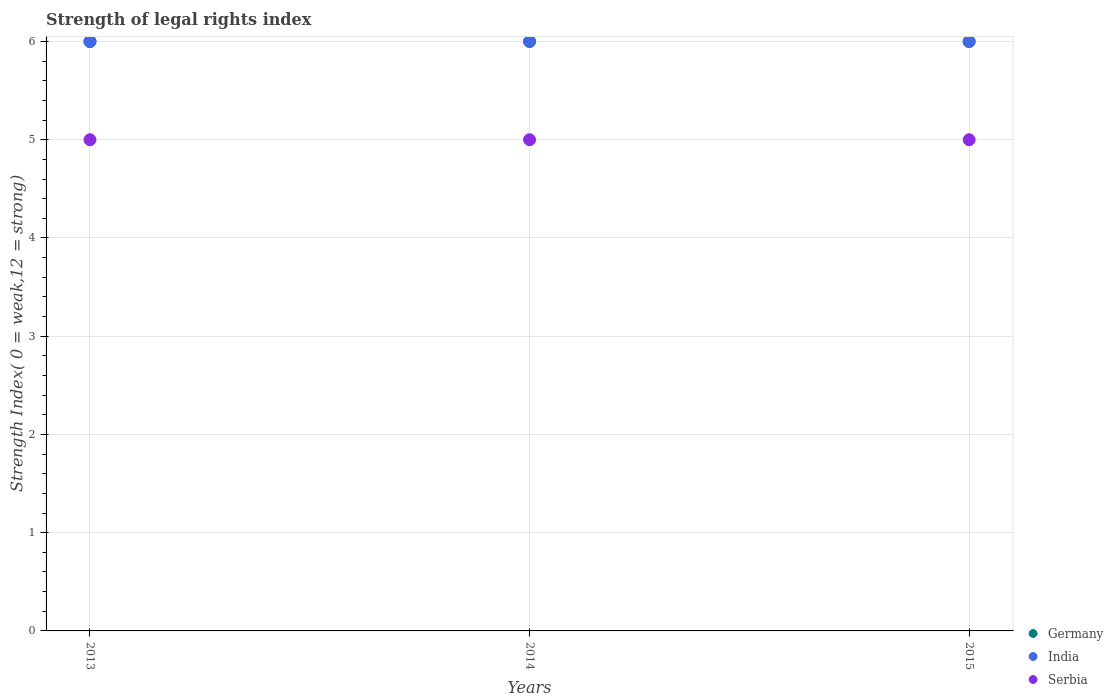Is the number of dotlines equal to the number of legend labels?
Ensure brevity in your answer.  Yes. Across all years, what is the maximum strength index in Germany?
Provide a succinct answer. 6. In which year was the strength index in India minimum?
Give a very brief answer. 2013. What is the total strength index in Serbia in the graph?
Offer a very short reply. 15. What is the difference between the strength index in Serbia in 2015 and the strength index in India in 2014?
Your answer should be very brief. -1. In the year 2015, what is the difference between the strength index in India and strength index in Serbia?
Ensure brevity in your answer.  1. What is the ratio of the strength index in Germany in 2014 to that in 2015?
Give a very brief answer. 1. What is the difference between the highest and the lowest strength index in Serbia?
Your answer should be very brief. 0. In how many years, is the strength index in Serbia greater than the average strength index in Serbia taken over all years?
Your answer should be compact. 0. Is the sum of the strength index in Germany in 2013 and 2014 greater than the maximum strength index in India across all years?
Your answer should be very brief. Yes. Is the strength index in Serbia strictly greater than the strength index in India over the years?
Provide a short and direct response. No. Is the strength index in Germany strictly less than the strength index in India over the years?
Make the answer very short. No. Are the values on the major ticks of Y-axis written in scientific E-notation?
Ensure brevity in your answer.  No. Does the graph contain grids?
Your answer should be very brief. Yes. How many legend labels are there?
Make the answer very short. 3. What is the title of the graph?
Your answer should be very brief. Strength of legal rights index. What is the label or title of the X-axis?
Make the answer very short. Years. What is the label or title of the Y-axis?
Ensure brevity in your answer.  Strength Index( 0 = weak,12 = strong). What is the Strength Index( 0 = weak,12 = strong) in Germany in 2013?
Provide a short and direct response. 6. What is the Strength Index( 0 = weak,12 = strong) of India in 2013?
Ensure brevity in your answer.  6. What is the Strength Index( 0 = weak,12 = strong) in Serbia in 2013?
Provide a short and direct response. 5. What is the Strength Index( 0 = weak,12 = strong) in India in 2014?
Keep it short and to the point. 6. What is the Strength Index( 0 = weak,12 = strong) in Serbia in 2014?
Your answer should be very brief. 5. What is the Strength Index( 0 = weak,12 = strong) of India in 2015?
Give a very brief answer. 6. What is the Strength Index( 0 = weak,12 = strong) of Serbia in 2015?
Ensure brevity in your answer.  5. Across all years, what is the maximum Strength Index( 0 = weak,12 = strong) in Germany?
Make the answer very short. 6. Across all years, what is the minimum Strength Index( 0 = weak,12 = strong) of Germany?
Your answer should be compact. 6. What is the total Strength Index( 0 = weak,12 = strong) of Serbia in the graph?
Your response must be concise. 15. What is the difference between the Strength Index( 0 = weak,12 = strong) in India in 2013 and that in 2014?
Your response must be concise. 0. What is the difference between the Strength Index( 0 = weak,12 = strong) of Serbia in 2013 and that in 2014?
Give a very brief answer. 0. What is the difference between the Strength Index( 0 = weak,12 = strong) in India in 2014 and that in 2015?
Provide a succinct answer. 0. What is the difference between the Strength Index( 0 = weak,12 = strong) in Germany in 2013 and the Strength Index( 0 = weak,12 = strong) in India in 2014?
Provide a succinct answer. 0. What is the difference between the Strength Index( 0 = weak,12 = strong) of Germany in 2013 and the Strength Index( 0 = weak,12 = strong) of Serbia in 2014?
Your answer should be very brief. 1. What is the difference between the Strength Index( 0 = weak,12 = strong) of India in 2013 and the Strength Index( 0 = weak,12 = strong) of Serbia in 2014?
Provide a short and direct response. 1. What is the difference between the Strength Index( 0 = weak,12 = strong) of Germany in 2013 and the Strength Index( 0 = weak,12 = strong) of Serbia in 2015?
Provide a succinct answer. 1. What is the difference between the Strength Index( 0 = weak,12 = strong) of Germany in 2014 and the Strength Index( 0 = weak,12 = strong) of Serbia in 2015?
Offer a terse response. 1. What is the difference between the Strength Index( 0 = weak,12 = strong) of India in 2014 and the Strength Index( 0 = weak,12 = strong) of Serbia in 2015?
Your response must be concise. 1. What is the average Strength Index( 0 = weak,12 = strong) of Germany per year?
Offer a terse response. 6. In the year 2013, what is the difference between the Strength Index( 0 = weak,12 = strong) in Germany and Strength Index( 0 = weak,12 = strong) in India?
Provide a short and direct response. 0. In the year 2013, what is the difference between the Strength Index( 0 = weak,12 = strong) of Germany and Strength Index( 0 = weak,12 = strong) of Serbia?
Offer a very short reply. 1. In the year 2013, what is the difference between the Strength Index( 0 = weak,12 = strong) in India and Strength Index( 0 = weak,12 = strong) in Serbia?
Your answer should be very brief. 1. In the year 2014, what is the difference between the Strength Index( 0 = weak,12 = strong) in Germany and Strength Index( 0 = weak,12 = strong) in India?
Keep it short and to the point. 0. In the year 2014, what is the difference between the Strength Index( 0 = weak,12 = strong) in India and Strength Index( 0 = weak,12 = strong) in Serbia?
Offer a terse response. 1. In the year 2015, what is the difference between the Strength Index( 0 = weak,12 = strong) of Germany and Strength Index( 0 = weak,12 = strong) of Serbia?
Offer a terse response. 1. In the year 2015, what is the difference between the Strength Index( 0 = weak,12 = strong) in India and Strength Index( 0 = weak,12 = strong) in Serbia?
Your answer should be compact. 1. What is the ratio of the Strength Index( 0 = weak,12 = strong) in India in 2013 to that in 2014?
Your response must be concise. 1. What is the ratio of the Strength Index( 0 = weak,12 = strong) in India in 2013 to that in 2015?
Provide a short and direct response. 1. What is the ratio of the Strength Index( 0 = weak,12 = strong) in Serbia in 2013 to that in 2015?
Keep it short and to the point. 1. What is the ratio of the Strength Index( 0 = weak,12 = strong) of Germany in 2014 to that in 2015?
Provide a short and direct response. 1. What is the difference between the highest and the second highest Strength Index( 0 = weak,12 = strong) of Serbia?
Give a very brief answer. 0. What is the difference between the highest and the lowest Strength Index( 0 = weak,12 = strong) in Germany?
Offer a terse response. 0. What is the difference between the highest and the lowest Strength Index( 0 = weak,12 = strong) in Serbia?
Your answer should be very brief. 0. 